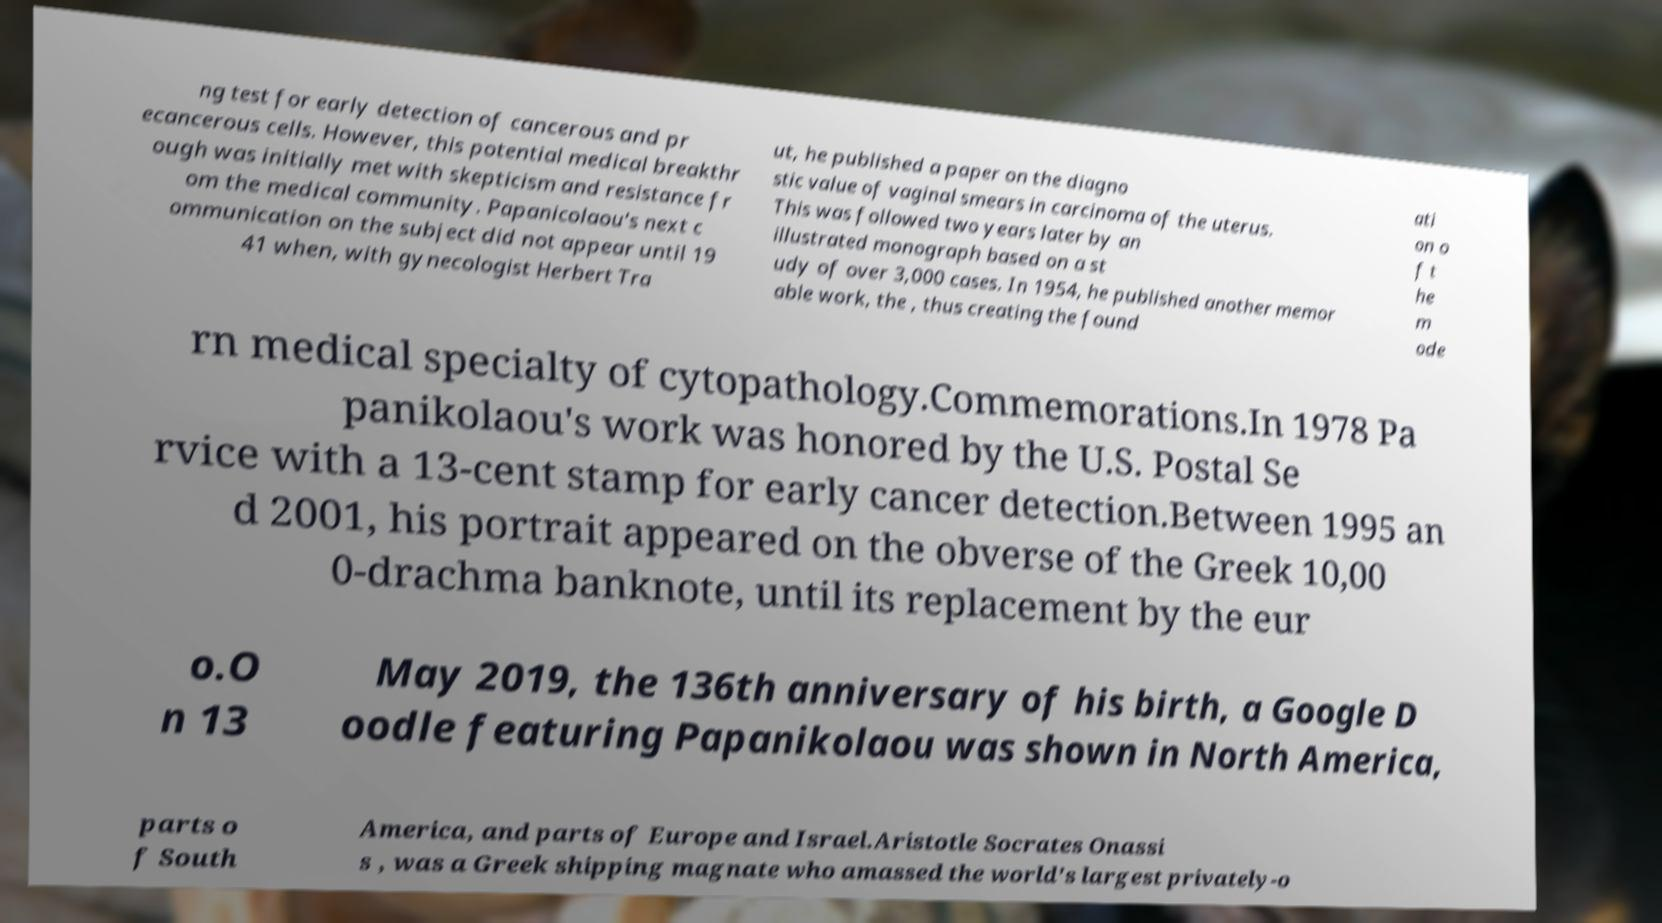Please read and relay the text visible in this image. What does it say? ng test for early detection of cancerous and pr ecancerous cells. However, this potential medical breakthr ough was initially met with skepticism and resistance fr om the medical community. Papanicolaou's next c ommunication on the subject did not appear until 19 41 when, with gynecologist Herbert Tra ut, he published a paper on the diagno stic value of vaginal smears in carcinoma of the uterus. This was followed two years later by an illustrated monograph based on a st udy of over 3,000 cases. In 1954, he published another memor able work, the , thus creating the found ati on o f t he m ode rn medical specialty of cytopathology.Commemorations.In 1978 Pa panikolaou's work was honored by the U.S. Postal Se rvice with a 13-cent stamp for early cancer detection.Between 1995 an d 2001, his portrait appeared on the obverse of the Greek 10,00 0-drachma banknote, until its replacement by the eur o.O n 13 May 2019, the 136th anniversary of his birth, a Google D oodle featuring Papanikolaou was shown in North America, parts o f South America, and parts of Europe and Israel.Aristotle Socrates Onassi s , was a Greek shipping magnate who amassed the world's largest privately-o 